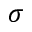Convert formula to latex. <formula><loc_0><loc_0><loc_500><loc_500>\sigma</formula> 